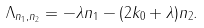Convert formula to latex. <formula><loc_0><loc_0><loc_500><loc_500>\Lambda _ { n _ { 1 } , n _ { 2 } } = - \lambda n _ { 1 } - ( 2 k _ { 0 } + \lambda ) n _ { 2 } .</formula> 